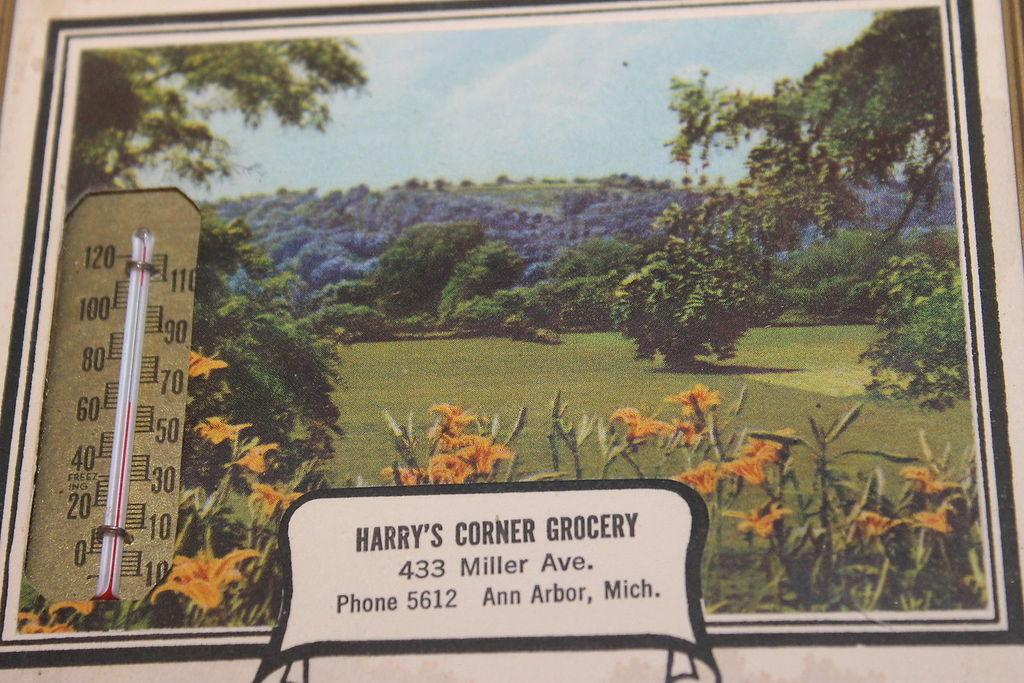<image>
Provide a brief description of the given image. A thermometer and address for Harry's Corner Grocery against a scenic backdrop 